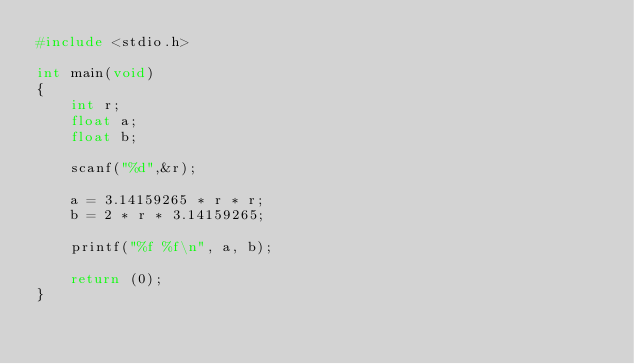<code> <loc_0><loc_0><loc_500><loc_500><_C_>#include <stdio.h>

int main(void)
{
	int r;
	float a;
	float b;
	
	scanf("%d",&r);
	
	a = 3.14159265 * r * r;
	b = 2 * r * 3.14159265;
	
	printf("%f %f\n", a, b);
	
	return (0);
}</code> 